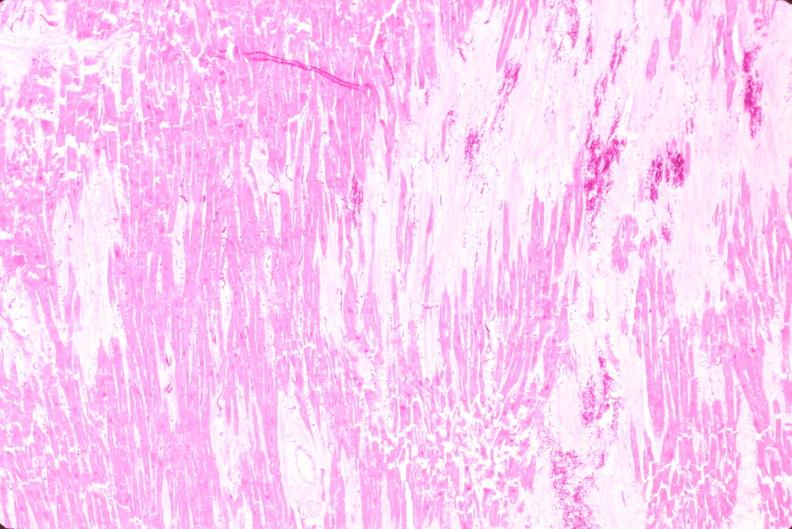s cardiovascular present?
Answer the question using a single word or phrase. Yes 